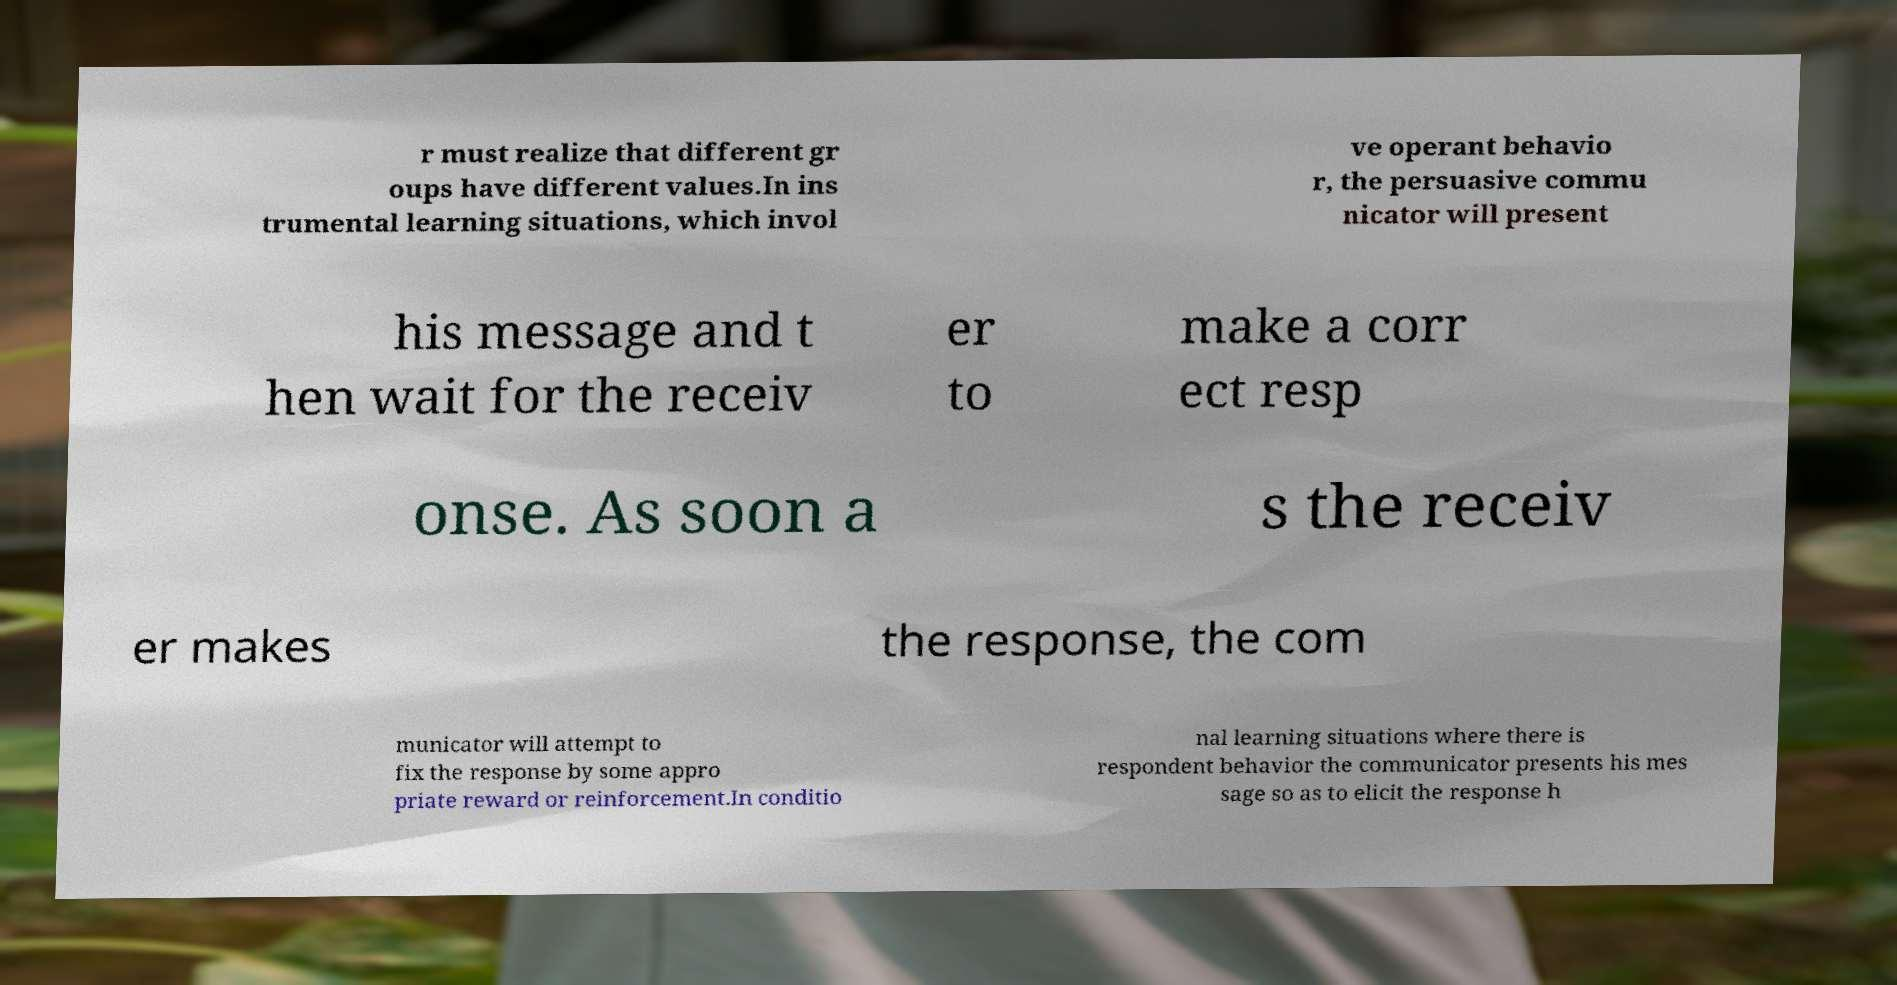What messages or text are displayed in this image? I need them in a readable, typed format. r must realize that different gr oups have different values.In ins trumental learning situations, which invol ve operant behavio r, the persuasive commu nicator will present his message and t hen wait for the receiv er to make a corr ect resp onse. As soon a s the receiv er makes the response, the com municator will attempt to fix the response by some appro priate reward or reinforcement.In conditio nal learning situations where there is respondent behavior the communicator presents his mes sage so as to elicit the response h 